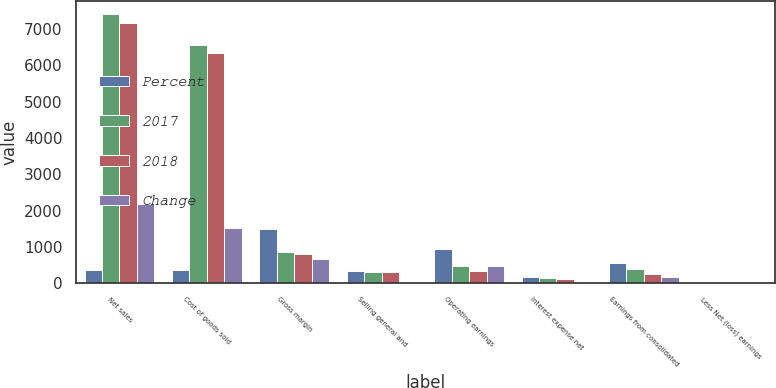<chart> <loc_0><loc_0><loc_500><loc_500><stacked_bar_chart><ecel><fcel>Net sales<fcel>Cost of goods sold<fcel>Gross margin<fcel>Selling general and<fcel>Operating earnings<fcel>Interest expense net<fcel>Earnings from consolidated<fcel>Less Net (loss) earnings<nl><fcel>Percent<fcel>357.55<fcel>357.55<fcel>1498.4<fcel>341.1<fcel>928.3<fcel>166.1<fcel>551.5<fcel>0.1<nl><fcel>2017<fcel>7409.4<fcel>6566.6<fcel>842.8<fcel>301.3<fcel>465.7<fcel>138.1<fcel>374<fcel>3<nl><fcel>2018<fcel>7162.8<fcel>6352.8<fcel>810<fcel>304.2<fcel>319<fcel>112.4<fcel>242.4<fcel>3.4<nl><fcel>Change<fcel>2177.9<fcel>1522.3<fcel>655.6<fcel>39.8<fcel>462.6<fcel>28<fcel>177.5<fcel>3.1<nl></chart> 